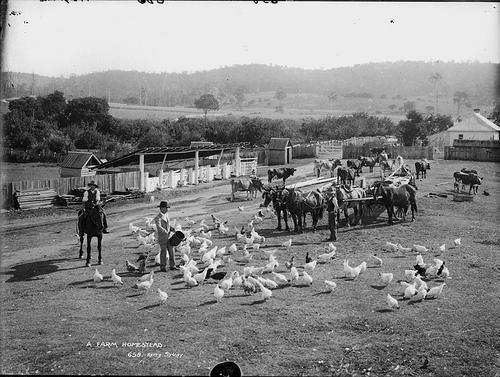How many birds are there?
Give a very brief answer. 22. Is this a old picture?
Write a very short answer. Yes. What are the horses on the far left attached to?
Answer briefly. Cart. What kind of material is the wall made of?
Short answer required. Wood. What animal is walking down the street?
Concise answer only. Horse. Are the chicken in a coop?
Concise answer only. No. How many animals are there?
Answer briefly. 40. Is the man a cook?
Write a very short answer. No. What type of event is taking place in the arena?
Short answer required. Feeding. What kind of animal is pictured?
Be succinct. Chicken. How many different kinds of animals are shown in this picture?
Write a very short answer. 3. 